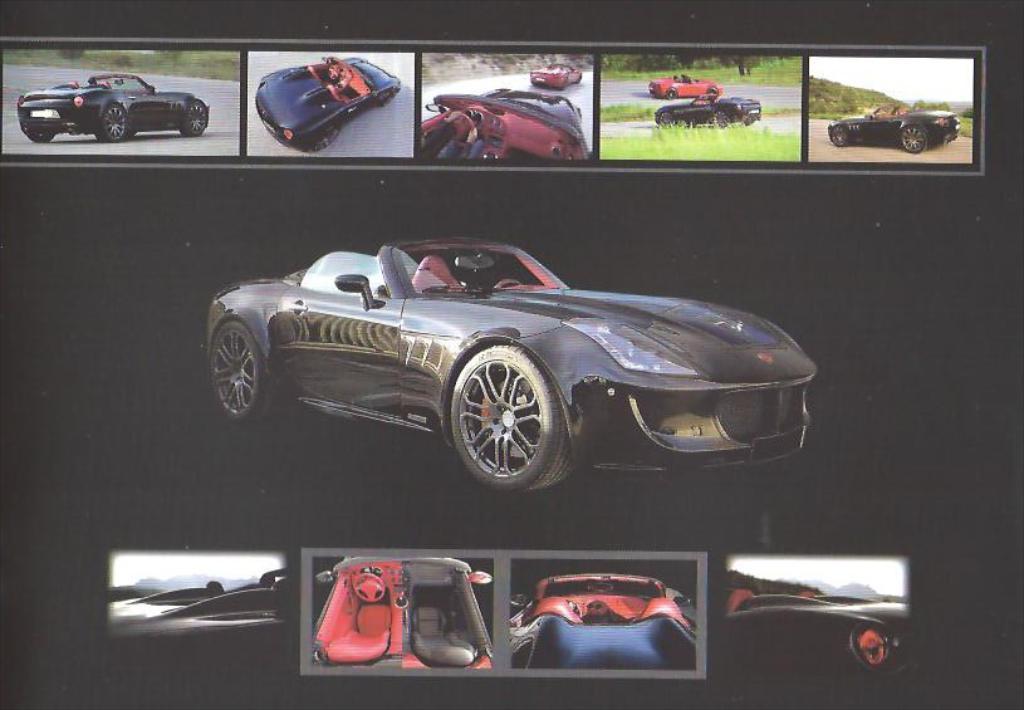In one or two sentences, can you explain what this image depicts? This is an edited image in which there are cars, there is grass on the ground, there are trees and there are mountains and there are cars moving on the road. 